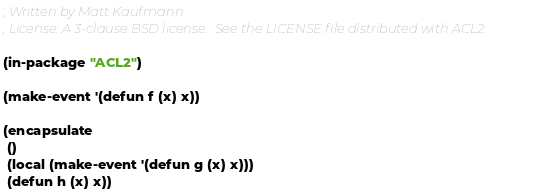<code> <loc_0><loc_0><loc_500><loc_500><_Lisp_>; Written by Matt Kaufmann
; License: A 3-clause BSD license.  See the LICENSE file distributed with ACL2.

(in-package "ACL2")

(make-event '(defun f (x) x))

(encapsulate
 ()
 (local (make-event '(defun g (x) x)))
 (defun h (x) x))
</code> 